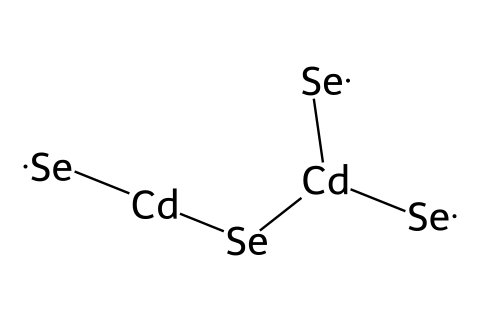What are the main elements in the cadmium selenide quantum dots? The SMILES representation indicates the presence of Cadmium (Cd) and Selenium (Se) in the structure.
Answer: Cadmium and Selenium How many Cadmium atoms are present in the structure? Looking at the SMILES, we see there are two instances of [Cd], indicating two Cadmium atoms in the structure.
Answer: 2 What is the total number of Selenium atoms in the cadmium selenide quantum dots? The SMILES shows four instances of [Se], thus there are four Selenium atoms within the structure.
Answer: 4 What type of bonds likely exist between the atoms? The chemical structure shows the atoms are connected without indicating any particular type, but generally, these elements form covalent bonds in quantum dots.
Answer: Covalent What is the coordination of Selenium atoms around Cadmium atoms? The structure indicates that each Cadmium atom is connected to multiple Selenium atoms, suggesting a tetrahedral coordination common in cadmium selenide.
Answer: Tetrahedral How does the chemical structure affect the optical properties of quantum dots? The arrangement of cadmium and selenium atoms contributes to the electronic bandgap, influencing the absorption and emission properties, which are crucial for their vivid colors in displays.
Answer: Influences bandgap What is the primary application of cadmium selenide quantum dots? The unique optical properties of these quantum dots make them particularly useful for displays and light-emitting diodes.
Answer: Displays 